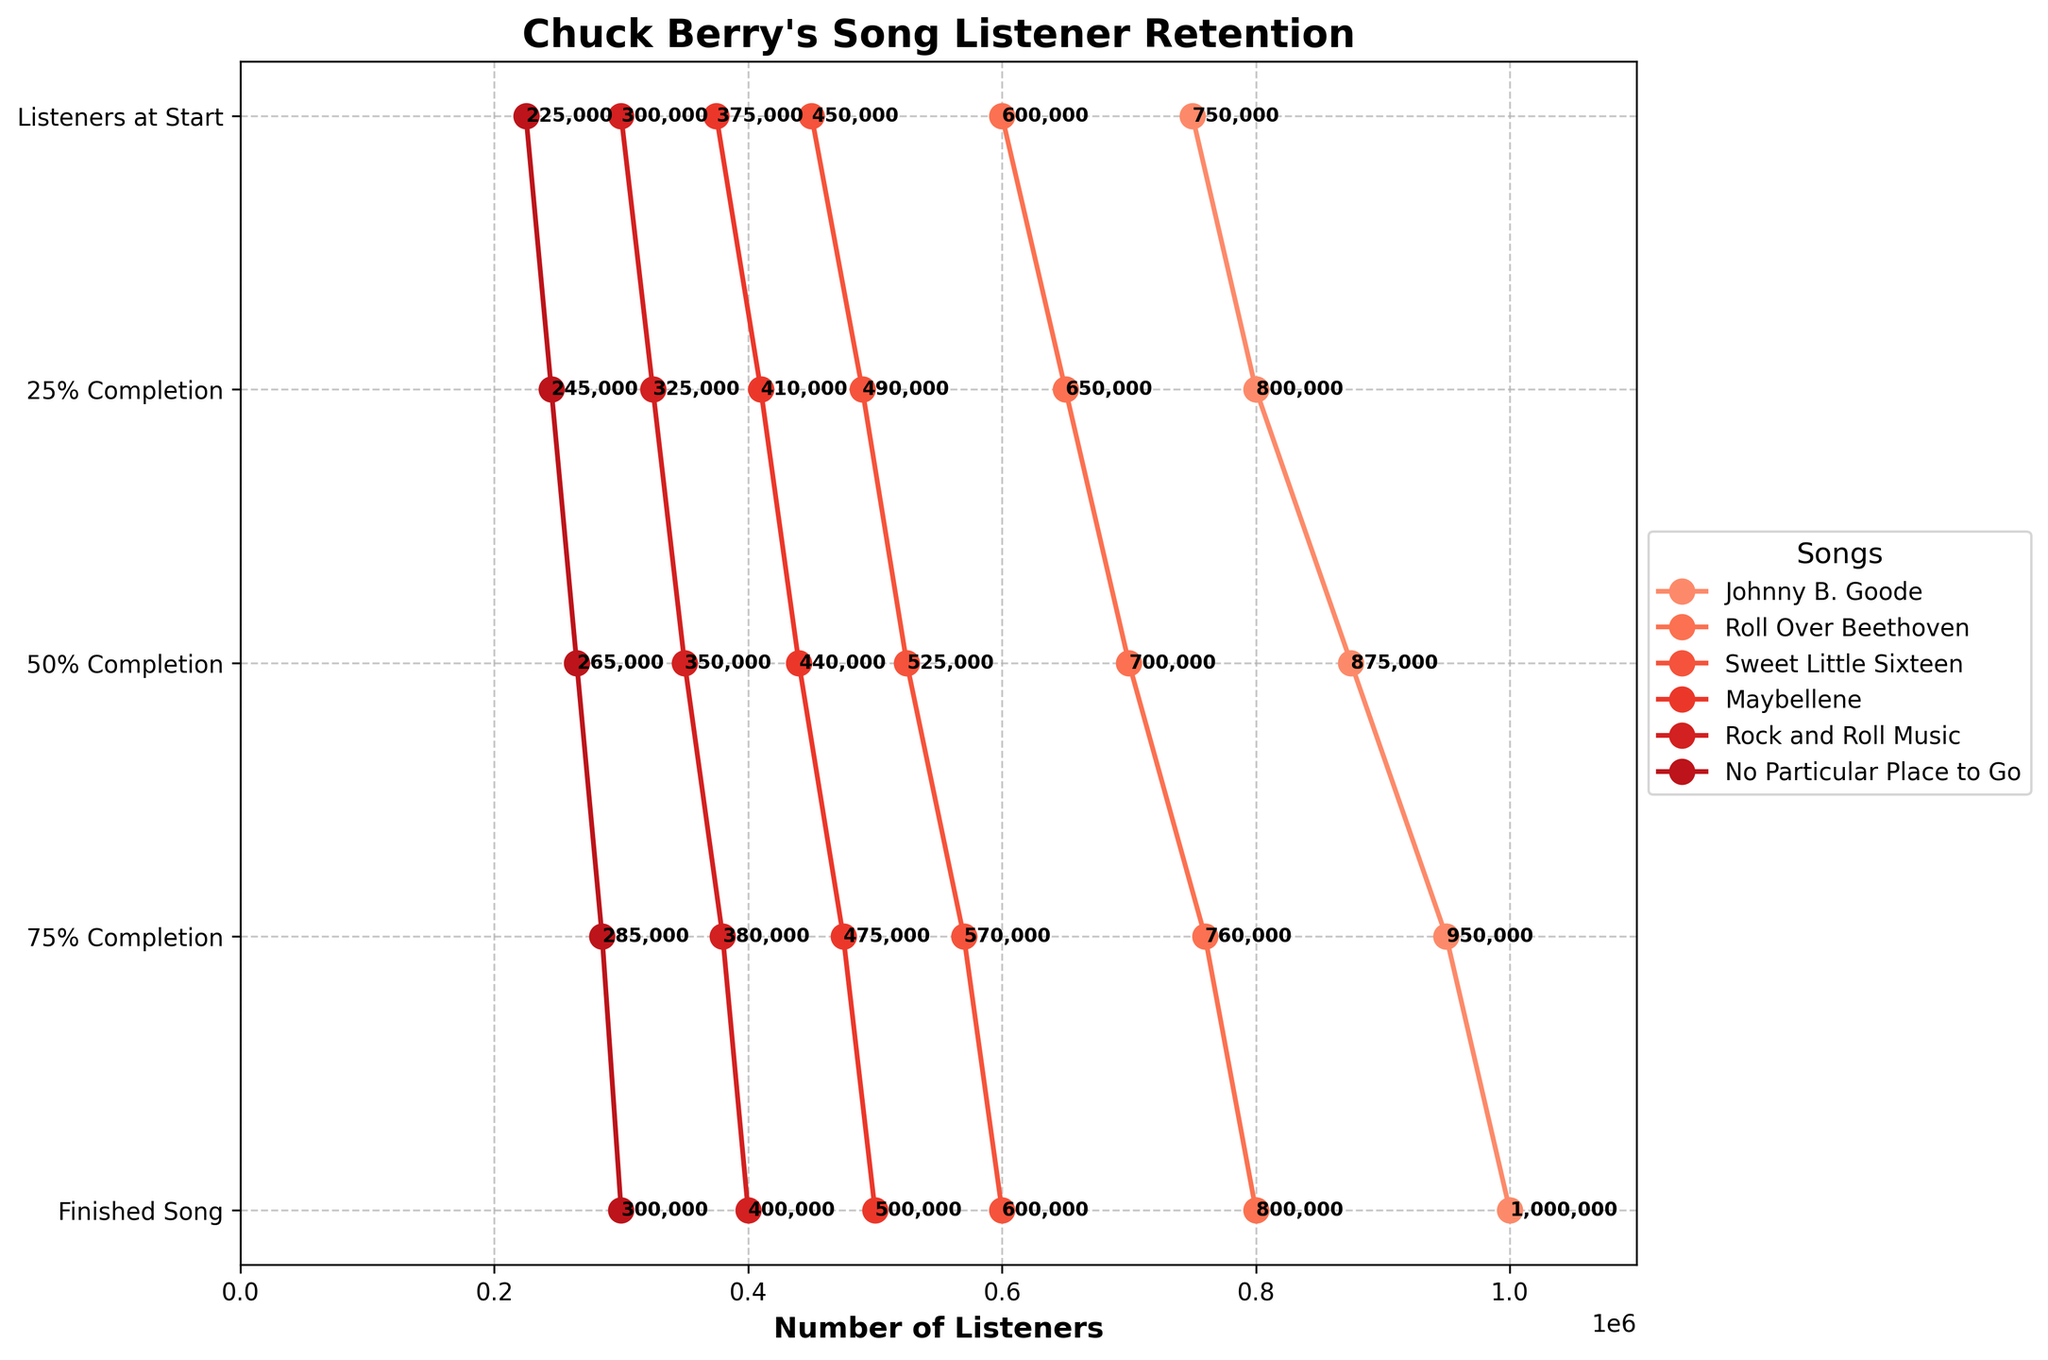What is the title of the chart? The title is positioned at the top of the chart and is labeled "Chuck Berry's Song Listener Retention".
Answer: Chuck Berry's Song Listener Retention How many songs are displayed on the chart? The chart legend lists the names of the songs, and there are a total of six songs.
Answer: 6 Which song has the highest number of listeners at the start? By looking at the chart for the highest starting point, "Johnny B. Goode" has the most listeners at 1,000,000.
Answer: Johnny B. Goode Which stage of "Roll Over Beethoven" retains the highest number of listeners? For "Roll Over Beethoven," the first stage (Listeners at Start) retains the most listeners at 800,000, as indicated by the top point in its plot line.
Answer: Listeners at Start At what percentage completion does "Sweet Little Sixteen" lose the most listeners? "Sweet Little Sixteen" has listeners dropping from 600,000 to 570,000 at 25% completion, which is the most significant drop.
Answer: 25% Completion What is the average number of listeners who finished "Maybellene" and "Rock and Roll Music"? Add the number of listeners who finished "Maybellene" and "Rock and Roll Music" (375,000 + 300,000) and divide by 2: (375,000 + 300,000)/2 = 337,500
Answer: 337,500 Which song shows the least drop-off in listener numbers from start to finish? By comparing the listener numbers drop from start to finish for all songs, “Roll Over Beethoven” shows the lowest drop-off, from 800,000 to 600,000, a drop of 200,000 listeners.
Answer: Roll Over Beethoven How does the listener retention of "No Particular Place to Go" compare to "Johnny B. Goode" at the 50% completion mark? "No Particular Place to Go" has 265,000 listeners at 50% completion, while "Johnny B. Goode" has 875,000 listeners at the same stage. Comparing the two shows “Johnny B. Goode” retains significantly more listeners.
Answer: Johnny B. Goode retains more listeners Which completion stage has the most significant drop for "Rock and Roll Music"? “Rock and Roll Music” drops from 400,000 to 380,000 listeners at the 25% completion stage, marking it as the most significant drop.
Answer: 25% Completion What percentage of the initial listeners finished the song "Johnny B. Goode"? The initial listeners are 1,000,000, and 750,000 finished the song. To find the percentage: (750,000 / 1,000,000) * 100 = 75%.
Answer: 75% 